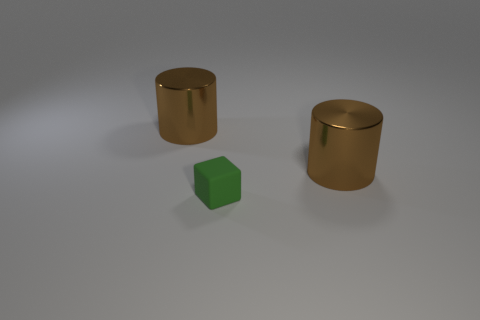The tiny matte object is what shape?
Give a very brief answer. Cube. How many other things are the same shape as the green object?
Provide a short and direct response. 0. There is a big metallic cylinder that is to the left of the green object; what is its color?
Your answer should be compact. Brown. How many things are small yellow cubes or brown metallic cylinders left of the small rubber object?
Your response must be concise. 1. What shape is the big object on the left side of the green cube?
Give a very brief answer. Cylinder. Does the thing that is to the right of the green cube have the same color as the rubber object?
Keep it short and to the point. No. There is a brown cylinder that is on the right side of the green block; is its size the same as the matte thing?
Keep it short and to the point. No. Are there any large metal objects of the same color as the matte cube?
Your response must be concise. No. Is there a large thing that is to the right of the cylinder left of the green matte block?
Ensure brevity in your answer.  Yes. Are there any green blocks that have the same material as the green object?
Your response must be concise. No. 